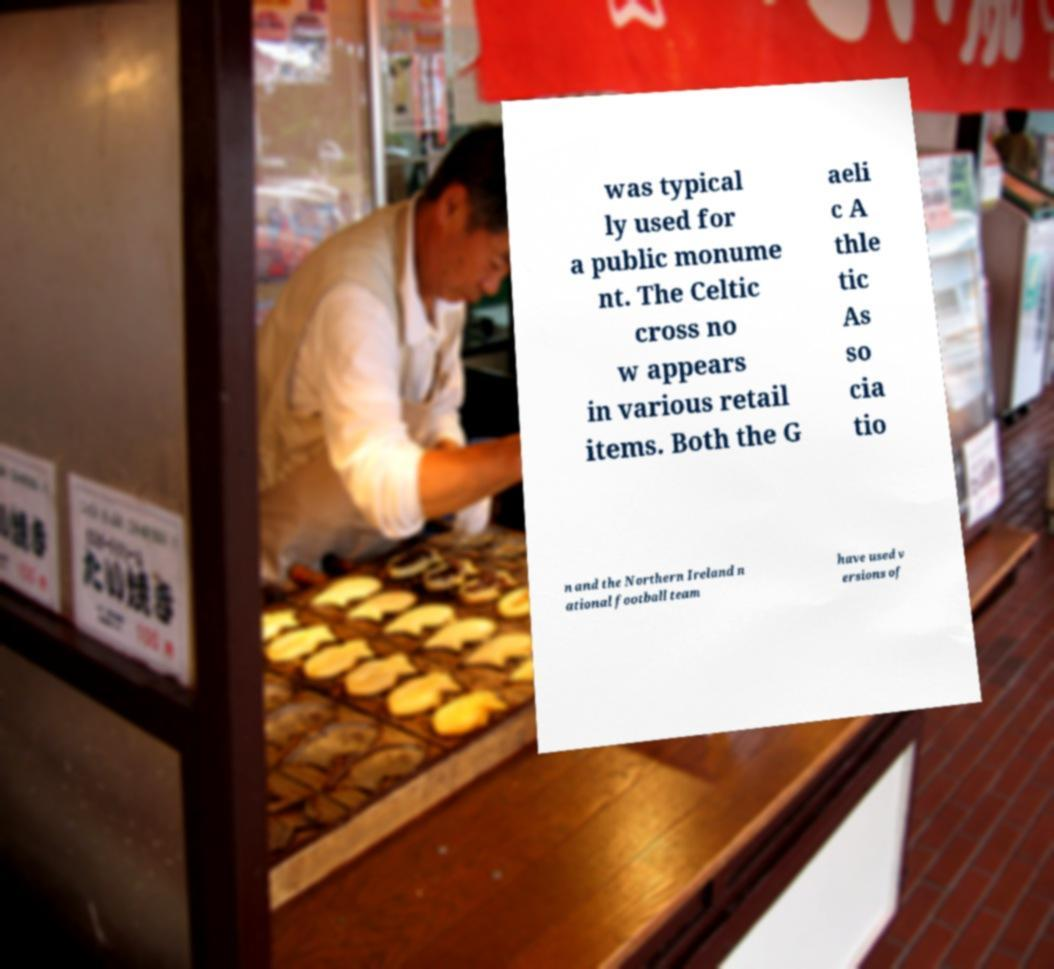Can you accurately transcribe the text from the provided image for me? was typical ly used for a public monume nt. The Celtic cross no w appears in various retail items. Both the G aeli c A thle tic As so cia tio n and the Northern Ireland n ational football team have used v ersions of 